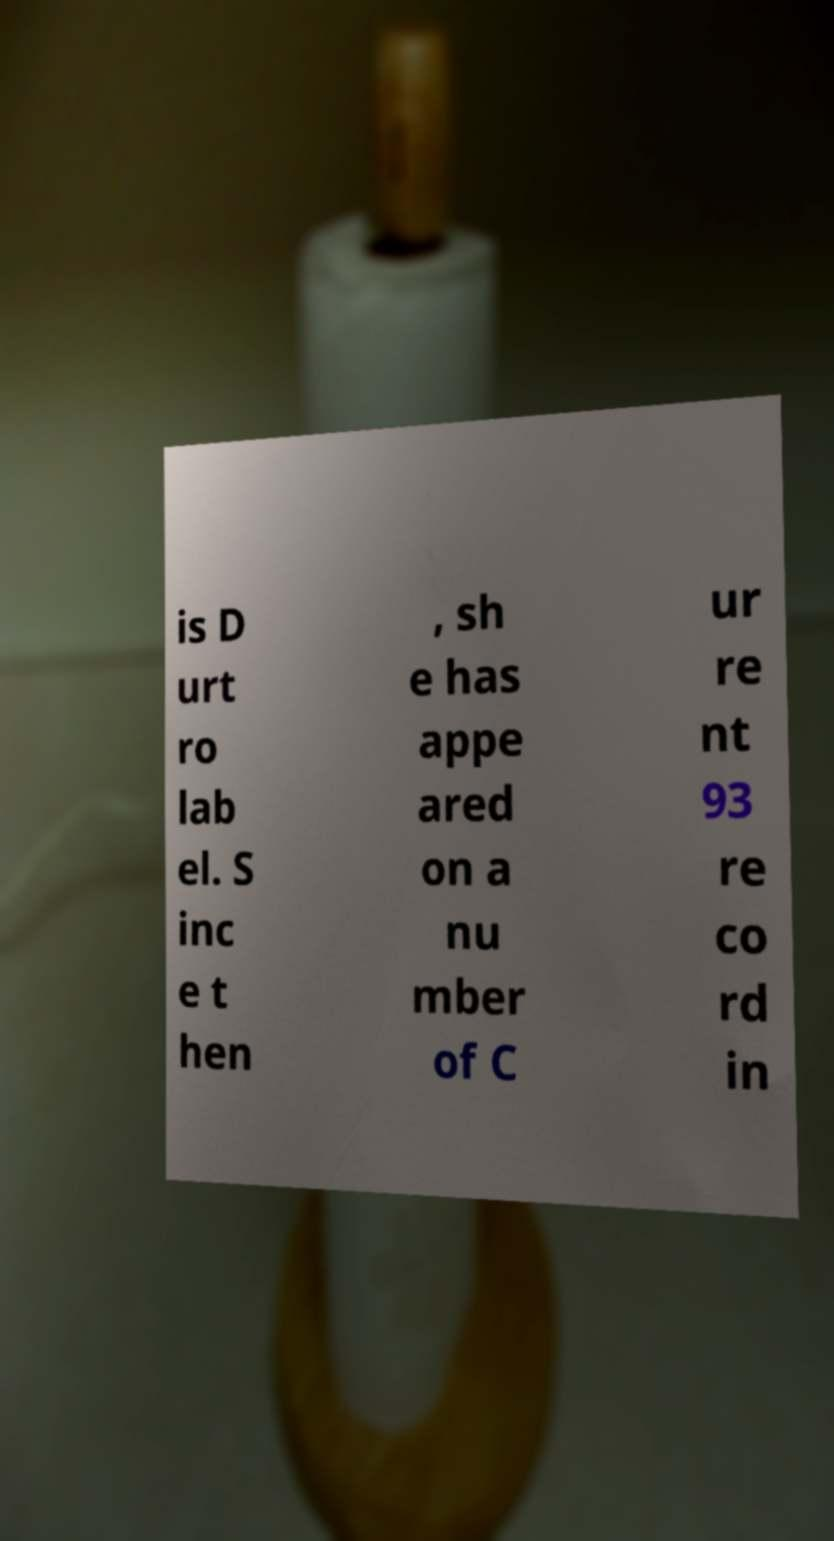I need the written content from this picture converted into text. Can you do that? is D urt ro lab el. S inc e t hen , sh e has appe ared on a nu mber of C ur re nt 93 re co rd in 